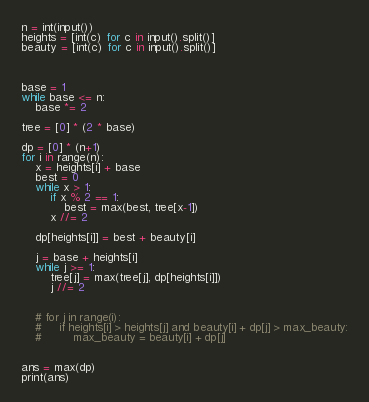Convert code to text. <code><loc_0><loc_0><loc_500><loc_500><_Python_>n = int(input())
heights = [int(c) for c in input().split()]
beauty = [int(c) for c in input().split()]



base = 1
while base <= n:
    base *= 2

tree = [0] * (2 * base)

dp = [0] * (n+1)
for i in range(n):
    x = heights[i] + base
    best = 0
    while x > 1:
        if x % 2 == 1:
            best = max(best, tree[x-1])
        x //= 2

    dp[heights[i]] = best + beauty[i]

    j = base + heights[i]
    while j >= 1:
        tree[j] = max(tree[j], dp[heights[i]])
        j //= 2


    # for j in range(i):
    #     if heights[i] > heights[j] and beauty[i] + dp[j] > max_beauty:
    #         max_beauty = beauty[i] + dp[j]


ans = max(dp)
print(ans)
</code> 